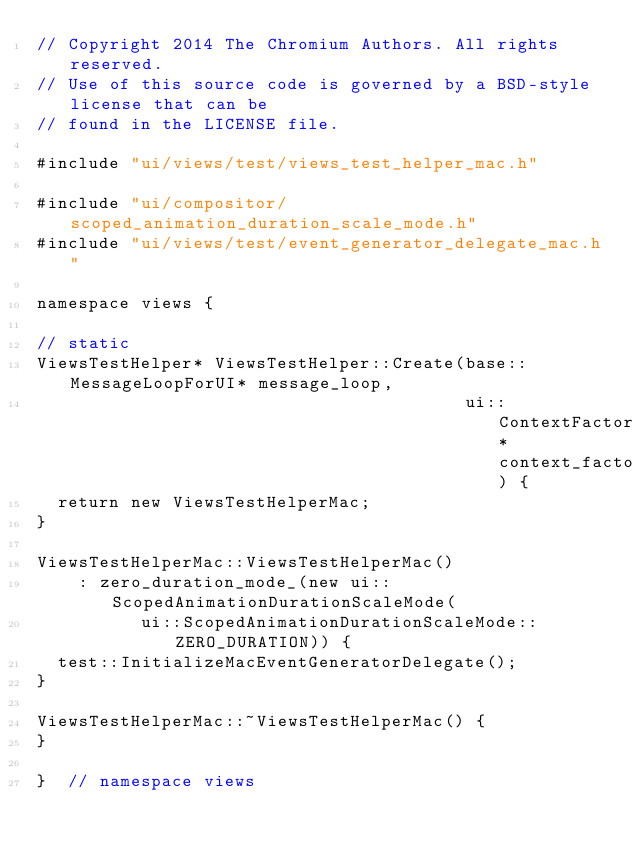Convert code to text. <code><loc_0><loc_0><loc_500><loc_500><_ObjectiveC_>// Copyright 2014 The Chromium Authors. All rights reserved.
// Use of this source code is governed by a BSD-style license that can be
// found in the LICENSE file.

#include "ui/views/test/views_test_helper_mac.h"

#include "ui/compositor/scoped_animation_duration_scale_mode.h"
#include "ui/views/test/event_generator_delegate_mac.h"

namespace views {

// static
ViewsTestHelper* ViewsTestHelper::Create(base::MessageLoopForUI* message_loop,
                                         ui::ContextFactory* context_factory) {
  return new ViewsTestHelperMac;
}

ViewsTestHelperMac::ViewsTestHelperMac()
    : zero_duration_mode_(new ui::ScopedAnimationDurationScaleMode(
          ui::ScopedAnimationDurationScaleMode::ZERO_DURATION)) {
  test::InitializeMacEventGeneratorDelegate();
}

ViewsTestHelperMac::~ViewsTestHelperMac() {
}

}  // namespace views
</code> 